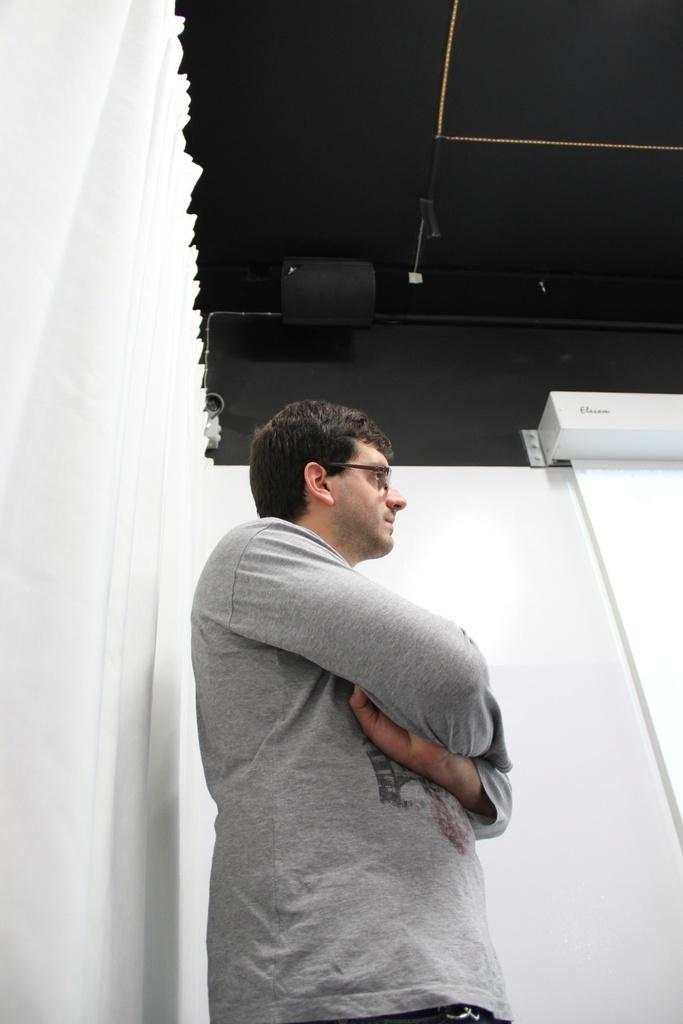What is the main subject of the image? There is a man standing in the middle of the image. What is located beside the man? There is a wall beside the man. What part of the room can be seen at the top of the image? The ceiling is visible at the top of the image. Can you tell me how many friends are sitting on the seat in the image? There is no seat or friends present in the image. Does the existence of the man in the image imply the existence of a specific object or person? The existence of the man in the image does not imply the existence of any specific object or person. 